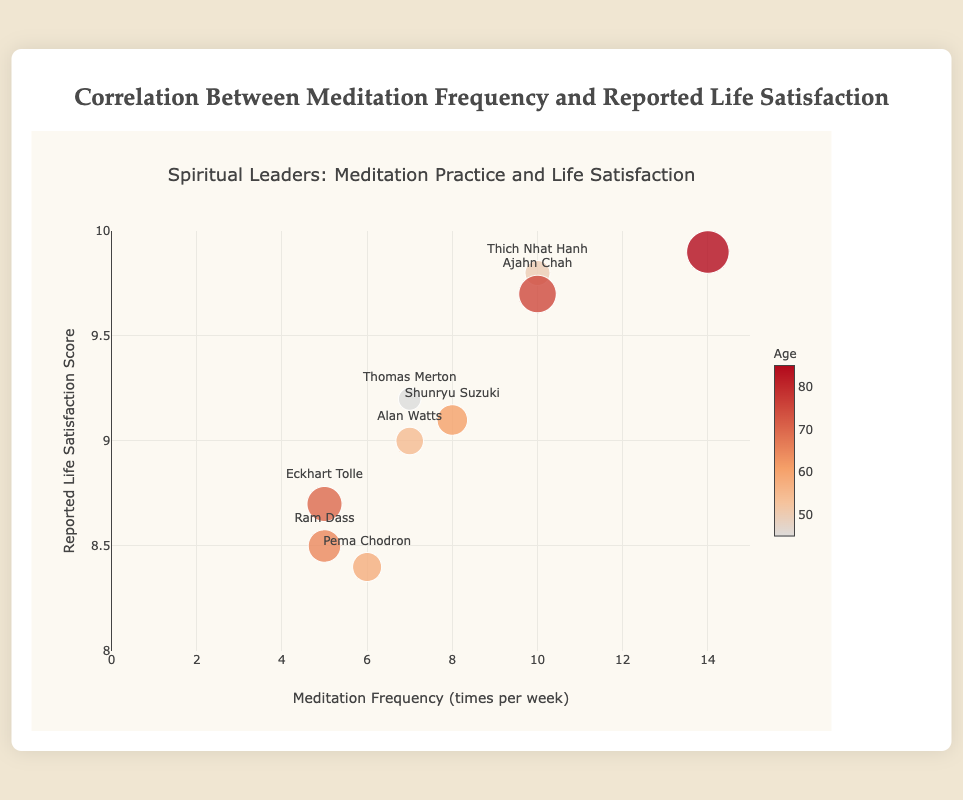What is the title of the figure? The title of the figure is displayed at the top.
Answer: Correlation Between Meditation Frequency and Reported Life Satisfaction How many people are represented in the plot? Each data point represents one person, and there are 9 data points in total.
Answer: 9 Which individual reports the highest life satisfaction score? By checking the y-axis values for the highest point, the highest life satisfaction score is reported by the Dalai Lama.
Answer: Dalai Lama What is the meditation frequency per week for Pema Chodron? Looking at the corresponding person label, Pema Chodron has a meditation frequency indicated on the x-axis.
Answer: 6 What is the average life satisfaction score among all the individuals? To find the average life satisfaction score, sum all the reported scores and divide by the number of individuals: (9.2 + 9.8 + 8.4 + 9.1 + 9.9 + 8.7 + 9.0 + 9.7 + 8.5)/9.
Answer: 9.03 Which person has the largest marker, and what does it imply about their age? The largest marker indicates the highest age. The Dalai Lama has the largest marker, showing they are the oldest at age 85.
Answer: Dalai Lama, 85 Compare the meditation frequency of Alan Watts and Ram Dass. Who meditates more? Look at the x-axis values for both individuals; Alan Watts has a meditation frequency of 7, while Ram Dass has a frequency of 5.
Answer: Alan Watts Is there a visible trend between meditation frequency and life satisfaction score? Observing the plot, points with higher meditation frequencies tend to show higher life satisfaction scores.
Answer: Yes What is the life satisfaction score difference between Thich Nhat Hanh and Alan Watts? Subtract the life satisfaction score of Alan Watts from Thich Nhat Hanh: 9.8 - 9.0.
Answer: 0.8 